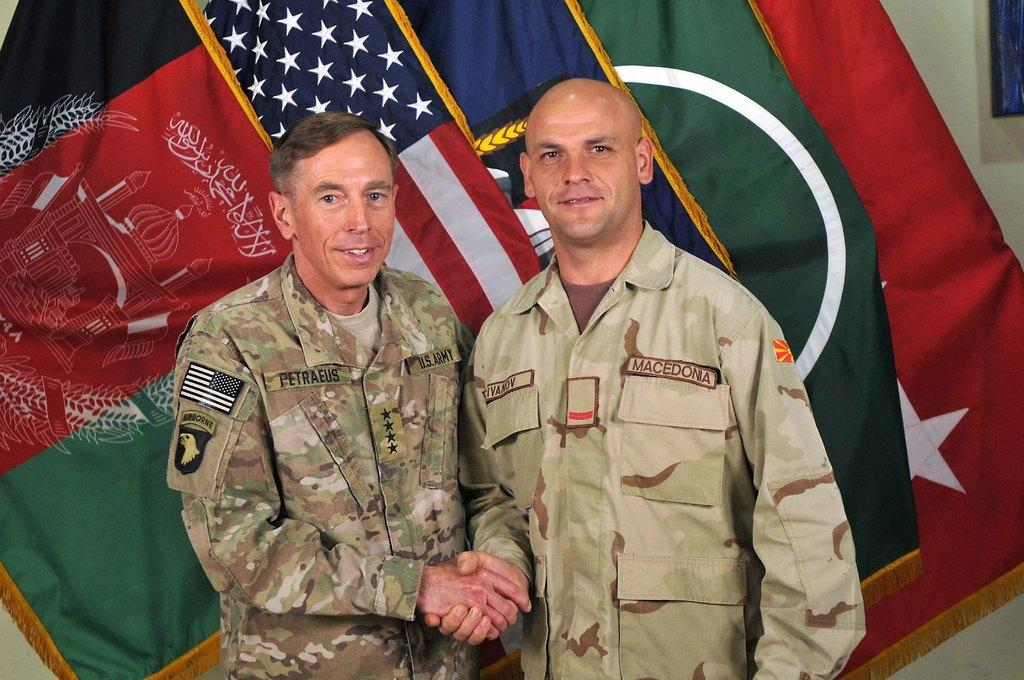How many people are in the image? There are two persons in the image. What are the persons wearing? The persons are wearing military dresses. What can be seen in the image besides the people? There are flags visible in the image. What is the chance of the persons paying off their debt in the image? There is no mention of debt in the image, so it is not possible to determine the chance of the persons paying off any debt. 